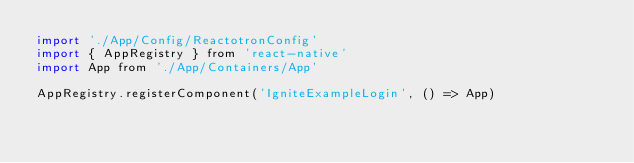<code> <loc_0><loc_0><loc_500><loc_500><_JavaScript_>import './App/Config/ReactotronConfig'
import { AppRegistry } from 'react-native'
import App from './App/Containers/App'

AppRegistry.registerComponent('IgniteExampleLogin', () => App)
</code> 